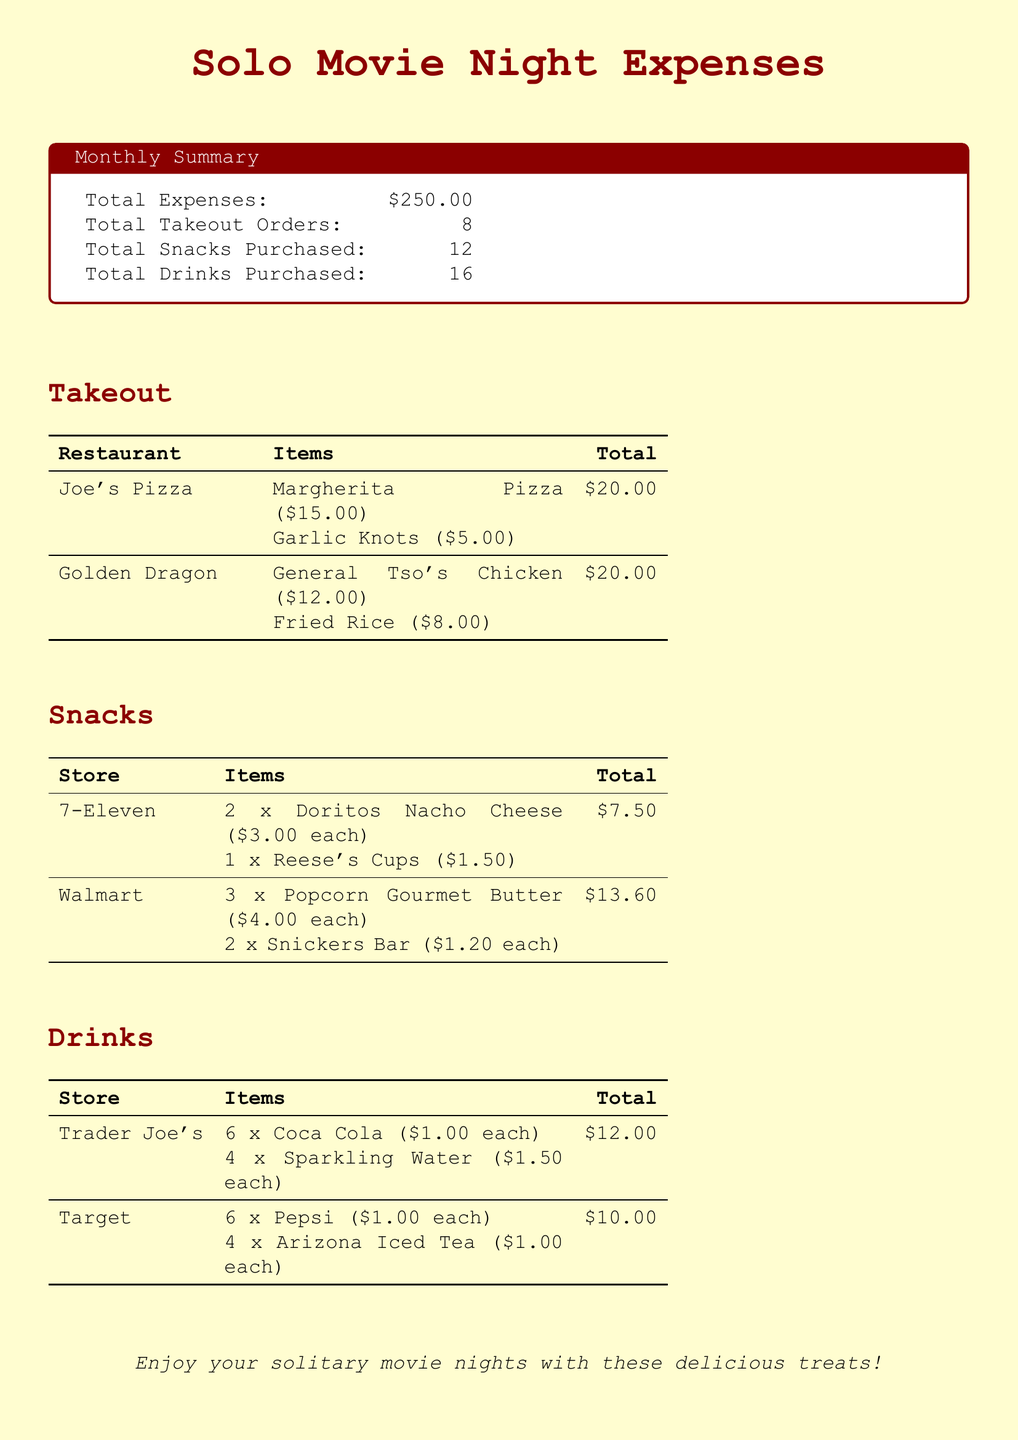What is the total expense? The total expense listed in the document is provided as the sum of all food and beverage expenses for the month.
Answer: $250.00 How many takeout orders were made? The number of takeout orders is explicitly stated in the summary section of the document.
Answer: 8 What snack was purchased from 7-Eleven? The document lists the specific items purchased from the store, indicating what was bought for snacks.
Answer: Doritos Nacho Cheese What was the total cost for drinks from Trader Joe's? The total cost for drinks is detailed under the drinks section, providing a breakdown by store.
Answer: $12.00 How many snacks were purchased in total? The document specifies the total number of snacks bought throughout the month in the summary section.
Answer: 12 What restaurant provided the garlic knots? The takeout section includes the restaurants and their respective items, identifying where the garlic knots were ordered from.
Answer: Joe's Pizza What type of pizza was ordered from Joe's Pizza? The specific type of pizza along with the associated cost can be found in the takeout section of the document.
Answer: Margherita Pizza What is the total for snacks purchased at Walmart? The total for the snacks from Walmart is clearly stated under the snacks section, showing how much was spent there.
Answer: $13.60 How many different types of drinks were purchased? The document includes a breakdown of items in the drinks section, which indicates the variety ordered.
Answer: 2 